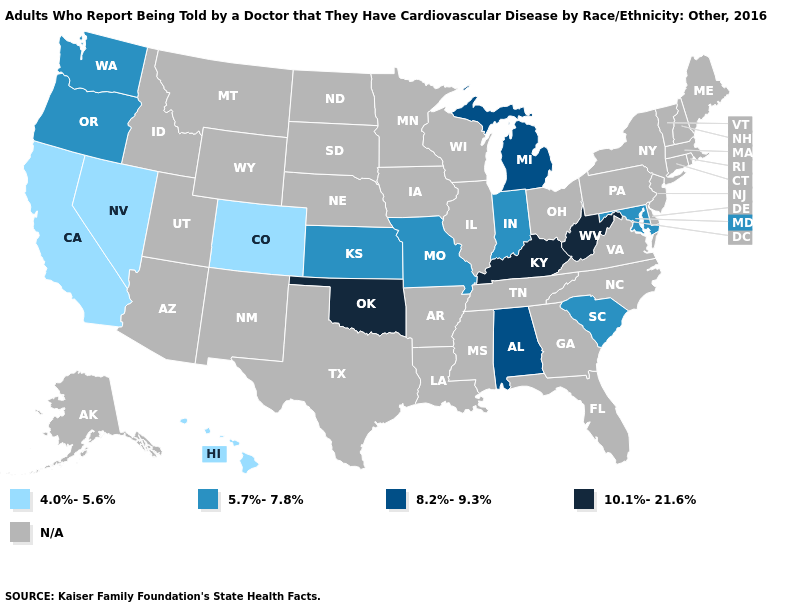How many symbols are there in the legend?
Short answer required. 5. Name the states that have a value in the range 4.0%-5.6%?
Quick response, please. California, Colorado, Hawaii, Nevada. What is the value of Maryland?
Be succinct. 5.7%-7.8%. Does West Virginia have the highest value in the USA?
Quick response, please. Yes. Is the legend a continuous bar?
Give a very brief answer. No. Does Washington have the highest value in the USA?
Short answer required. No. Is the legend a continuous bar?
Give a very brief answer. No. What is the value of Alaska?
Write a very short answer. N/A. Which states hav the highest value in the MidWest?
Give a very brief answer. Michigan. Name the states that have a value in the range N/A?
Answer briefly. Alaska, Arizona, Arkansas, Connecticut, Delaware, Florida, Georgia, Idaho, Illinois, Iowa, Louisiana, Maine, Massachusetts, Minnesota, Mississippi, Montana, Nebraska, New Hampshire, New Jersey, New Mexico, New York, North Carolina, North Dakota, Ohio, Pennsylvania, Rhode Island, South Dakota, Tennessee, Texas, Utah, Vermont, Virginia, Wisconsin, Wyoming. What is the highest value in the USA?
Give a very brief answer. 10.1%-21.6%. Which states hav the highest value in the South?
Concise answer only. Kentucky, Oklahoma, West Virginia. What is the lowest value in the USA?
Concise answer only. 4.0%-5.6%. 